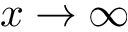<formula> <loc_0><loc_0><loc_500><loc_500>x \rightarrow \infty</formula> 